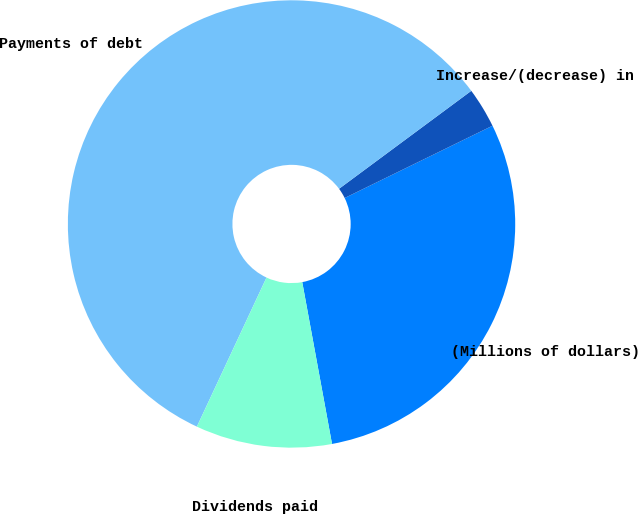<chart> <loc_0><loc_0><loc_500><loc_500><pie_chart><fcel>(Millions of dollars)<fcel>Increase/(decrease) in<fcel>Payments of debt<fcel>Dividends paid<nl><fcel>29.34%<fcel>2.91%<fcel>57.9%<fcel>9.85%<nl></chart> 